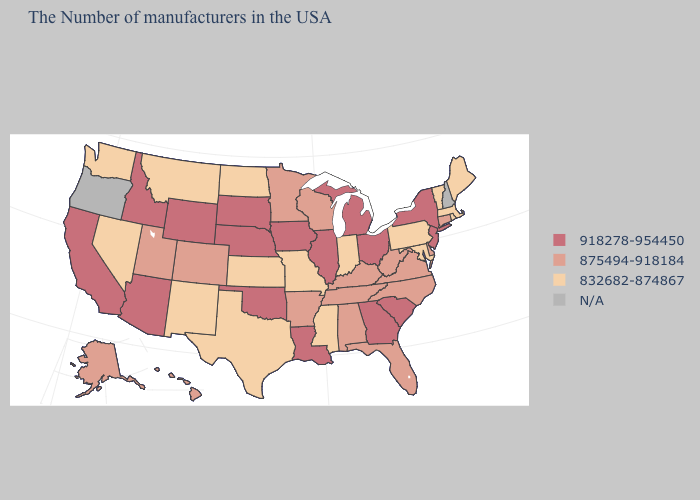What is the value of Pennsylvania?
Quick response, please. 832682-874867. Name the states that have a value in the range N/A?
Quick response, please. New Hampshire, Oregon. What is the value of Hawaii?
Write a very short answer. 875494-918184. Name the states that have a value in the range N/A?
Keep it brief. New Hampshire, Oregon. What is the value of Wisconsin?
Concise answer only. 875494-918184. What is the value of Maryland?
Answer briefly. 832682-874867. Among the states that border New Mexico , does Oklahoma have the highest value?
Keep it brief. Yes. What is the lowest value in the USA?
Give a very brief answer. 832682-874867. Does Massachusetts have the lowest value in the Northeast?
Give a very brief answer. Yes. Name the states that have a value in the range 918278-954450?
Quick response, please. New York, New Jersey, South Carolina, Ohio, Georgia, Michigan, Illinois, Louisiana, Iowa, Nebraska, Oklahoma, South Dakota, Wyoming, Arizona, Idaho, California. What is the value of Kansas?
Short answer required. 832682-874867. What is the value of Georgia?
Quick response, please. 918278-954450. Name the states that have a value in the range 918278-954450?
Concise answer only. New York, New Jersey, South Carolina, Ohio, Georgia, Michigan, Illinois, Louisiana, Iowa, Nebraska, Oklahoma, South Dakota, Wyoming, Arizona, Idaho, California. Among the states that border New York , which have the highest value?
Answer briefly. New Jersey. 